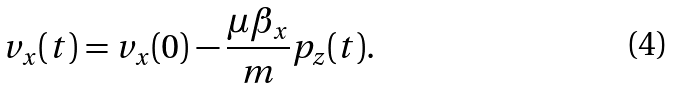<formula> <loc_0><loc_0><loc_500><loc_500>v _ { x } ( t ) = v _ { x } ( 0 ) - \frac { \mu \beta _ { x } } { m } p _ { z } ( t ) .</formula> 